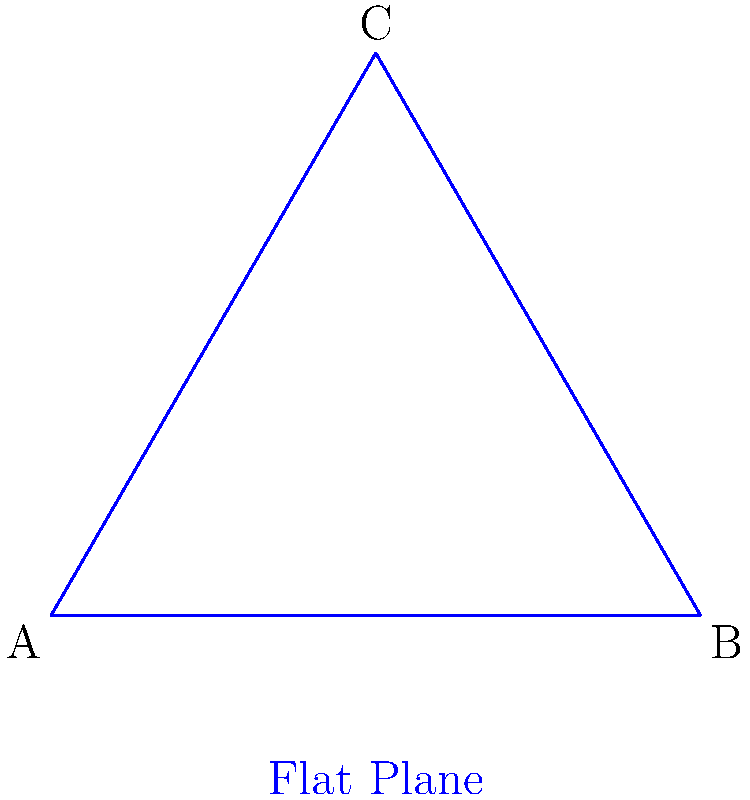As a cognitive psychologist studying human perception, you're examining how people interpret geometric relationships in different spaces. Consider the sum of interior angles in a triangle on a flat (Euclidean) plane versus a hyperbolic plane, as shown in the figure. If the sum of interior angles in the blue triangle on the flat plane is $180°$, what is the approximate sum of interior angles for the red triangle on the hyperbolic plane? Explain how this difference might affect spatial perception and attention in these different geometries. To understand the difference in angle sums between flat and hyperbolic planes:

1. Flat (Euclidean) plane:
   - The sum of interior angles in a triangle is always $180°$.
   - This is consistent with our everyday experience and intuition.

2. Hyperbolic plane:
   - The sum of interior angles in a triangle is always less than $180°$.
   - The exact sum depends on the size of the triangle, but it's always smaller than in Euclidean geometry.
   - As the triangle gets larger in hyperbolic space, the sum of its angles approaches $0°$.

3. For the given hyperbolic triangle:
   - Based on its size relative to the Poincaré disk, we can estimate the sum to be around $120°$ to $150°$.

4. Impact on spatial perception and attention:
   - In Euclidean space, our perception aligns with physical reality.
   - In hyperbolic space, there's a mismatch between perception and physical geometry.
   - This mismatch could lead to:
     a) Increased cognitive load when interpreting spatial relationships.
     b) Potential errors in distance and angle estimation.
     c) Altered attention allocation due to unexpected geometric properties.
   - These differences might require different cognitive strategies for spatial navigation and object recognition in hyperbolic versus Euclidean spaces.

5. Research implications:
   - This geometric difference could be used to study adaptability of human spatial cognition.
   - It may provide insights into how the brain processes and represents non-Euclidean spaces.
   - Could lead to new understandings of spatial attention and perception in curved or warped environments.
Answer: Less than $180°$, approximately $120°$ to $150°$. 